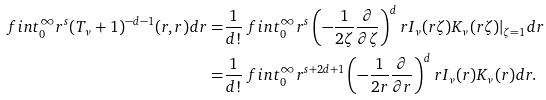<formula> <loc_0><loc_0><loc_500><loc_500>\ f i n t _ { 0 } ^ { \infty } r ^ { s } ( T _ { \nu } + 1 ) ^ { - d - 1 } ( r , r ) d r = & \frac { 1 } { d ! } \ f i n t _ { 0 } ^ { \infty } r ^ { s } \left ( - \frac { 1 } { 2 \zeta } \frac { \partial } { \partial \zeta } \right ) ^ { d } r I _ { \nu } ( r \zeta ) K _ { \nu } ( r \zeta ) | _ { \zeta = 1 } d r \\ = & \frac { 1 } { d ! } \ f i n t _ { 0 } ^ { \infty } r ^ { s + 2 d + 1 } \left ( - \frac { 1 } { 2 r } \frac { \partial } { \partial r } \right ) ^ { d } r I _ { \nu } ( r ) K _ { \nu } ( r ) d r .</formula> 